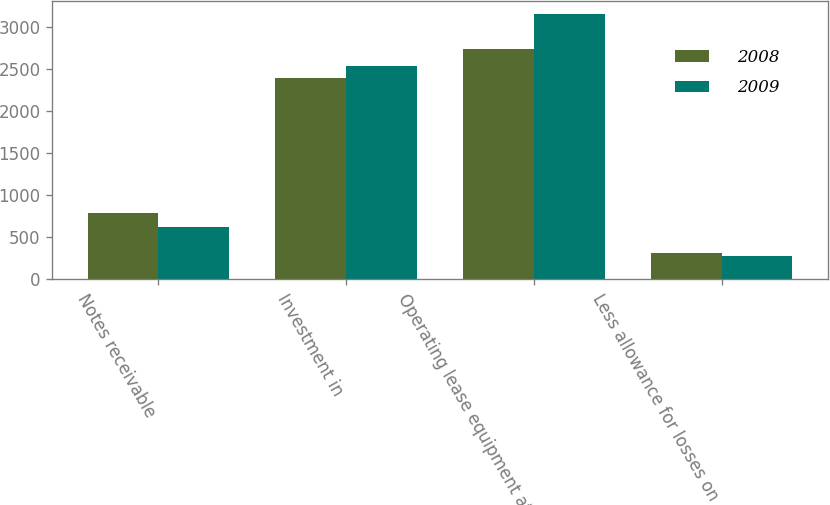Convert chart. <chart><loc_0><loc_0><loc_500><loc_500><stacked_bar_chart><ecel><fcel>Notes receivable<fcel>Investment in<fcel>Operating lease equipment at<fcel>Less allowance for losses on<nl><fcel>2008<fcel>779<fcel>2391<fcel>2737<fcel>302<nl><fcel>2009<fcel>615<fcel>2528<fcel>3152<fcel>269<nl></chart> 